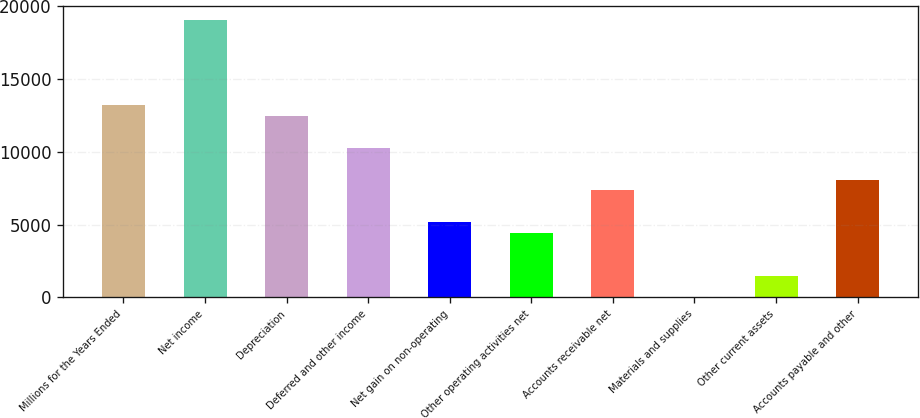<chart> <loc_0><loc_0><loc_500><loc_500><bar_chart><fcel>Millions for the Years Ended<fcel>Net income<fcel>Depreciation<fcel>Deferred and other income<fcel>Net gain on non-operating<fcel>Other operating activities net<fcel>Accounts receivable net<fcel>Materials and supplies<fcel>Other current assets<fcel>Accounts payable and other<nl><fcel>13200<fcel>19056<fcel>12468<fcel>10272<fcel>5148<fcel>4416<fcel>7344<fcel>24<fcel>1488<fcel>8076<nl></chart> 